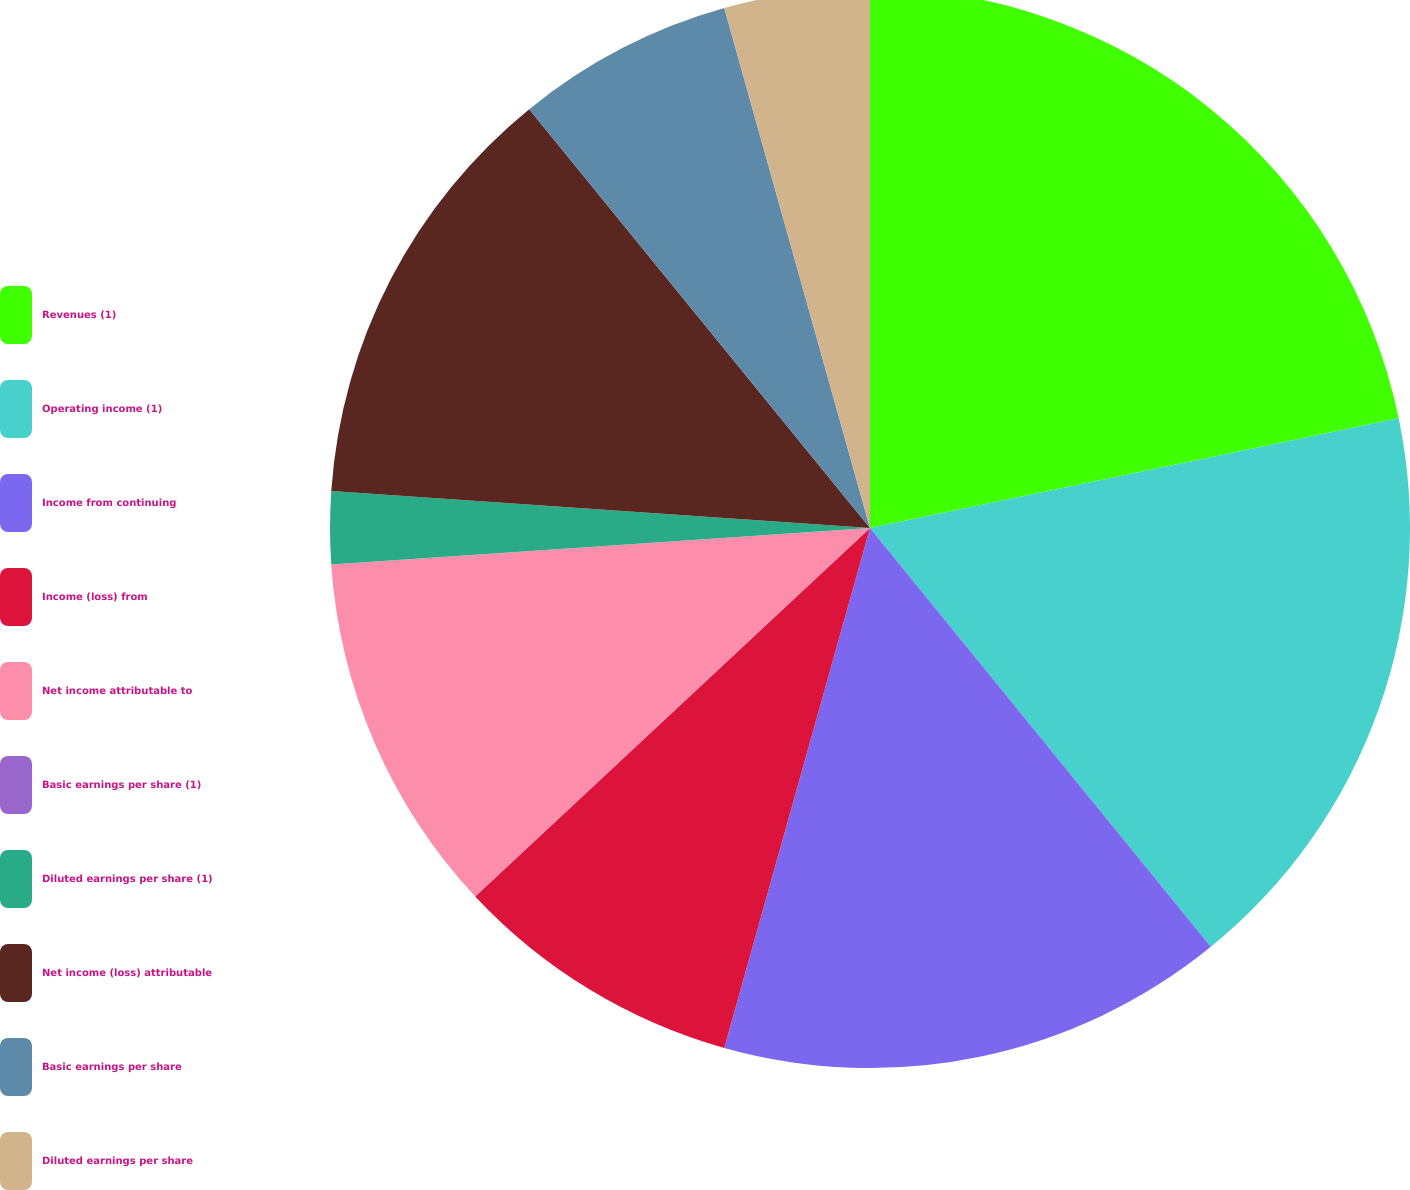<chart> <loc_0><loc_0><loc_500><loc_500><pie_chart><fcel>Revenues (1)<fcel>Operating income (1)<fcel>Income from continuing<fcel>Income (loss) from<fcel>Net income attributable to<fcel>Basic earnings per share (1)<fcel>Diluted earnings per share (1)<fcel>Net income (loss) attributable<fcel>Basic earnings per share<fcel>Diluted earnings per share<nl><fcel>21.74%<fcel>17.39%<fcel>15.22%<fcel>8.7%<fcel>10.87%<fcel>0.0%<fcel>2.17%<fcel>13.04%<fcel>6.52%<fcel>4.35%<nl></chart> 